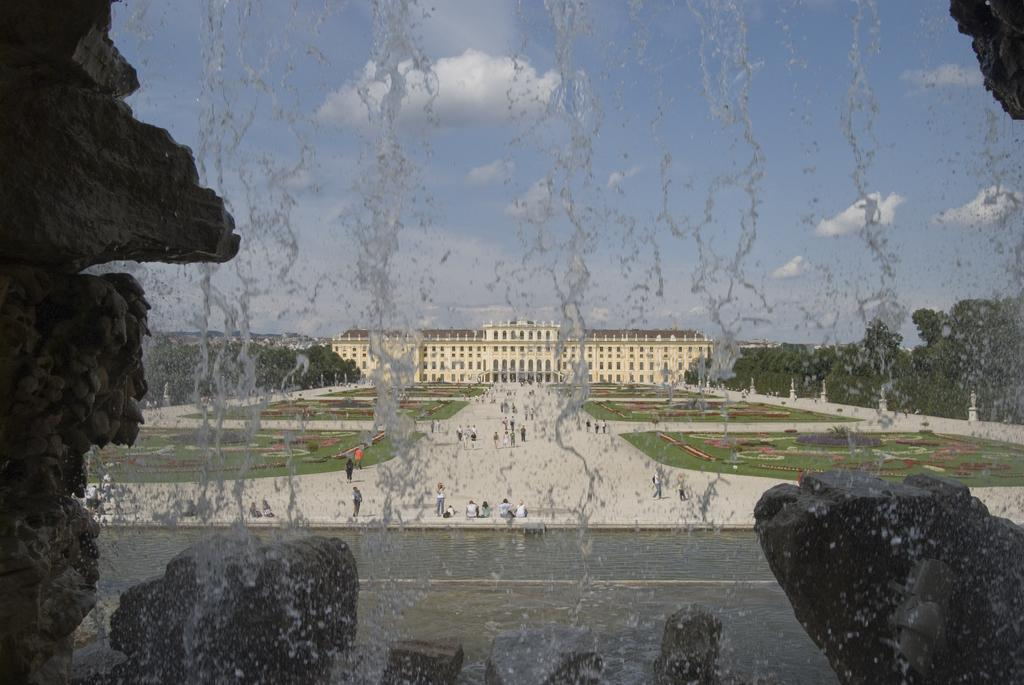What is happening with the rocks in the image? Water is flowing from rocks in the image. What structure can be seen in the middle of the image? There is a building in the middle of the image. What type of vegetation is present in the image? There are trees in the image. What musical instrument is being played in the image? There is no musical instrument present in the image. Can you tell me which language is being spoken in the image? There is no speech or language present in the image. 